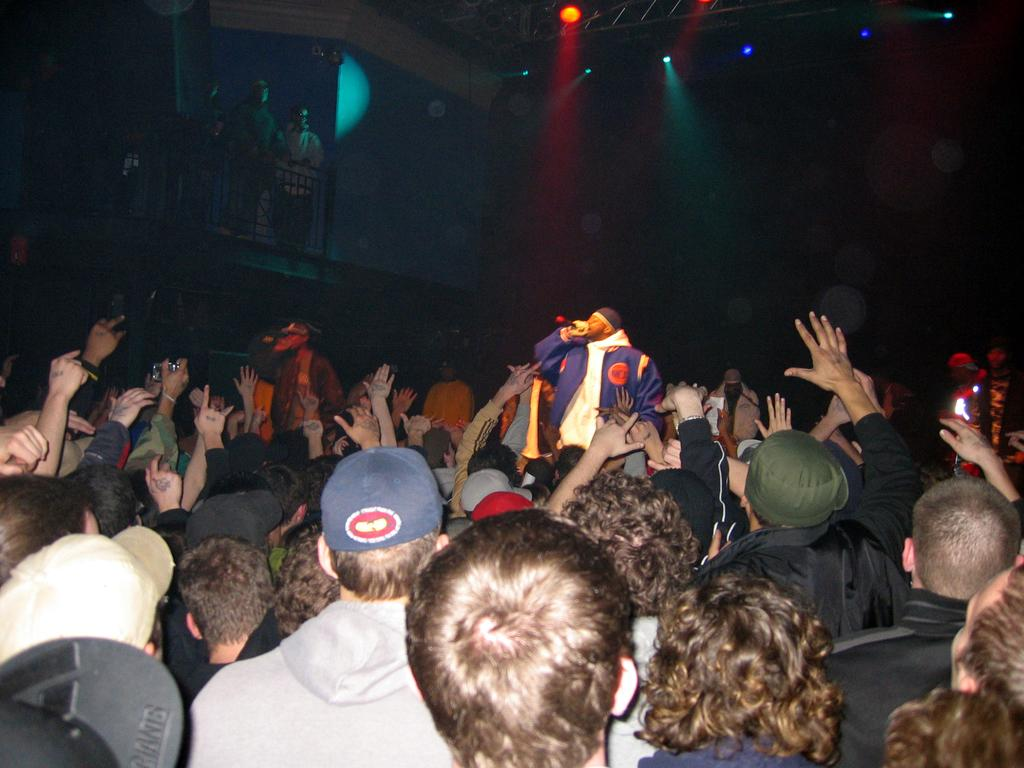What can be seen at the bottom of the image? There is a group of people at the bottom of the image. What are some people in the group wearing? Some people in the group are wearing caps. How would you describe the overall lighting in the image? The background of the image is dark, but there are lights visible in the background. What can be seen in the background of the image? There is a railing and people in the background. What type of cheese is being served on the sidewalk in the image? There is no cheese or sidewalk present in the image. 